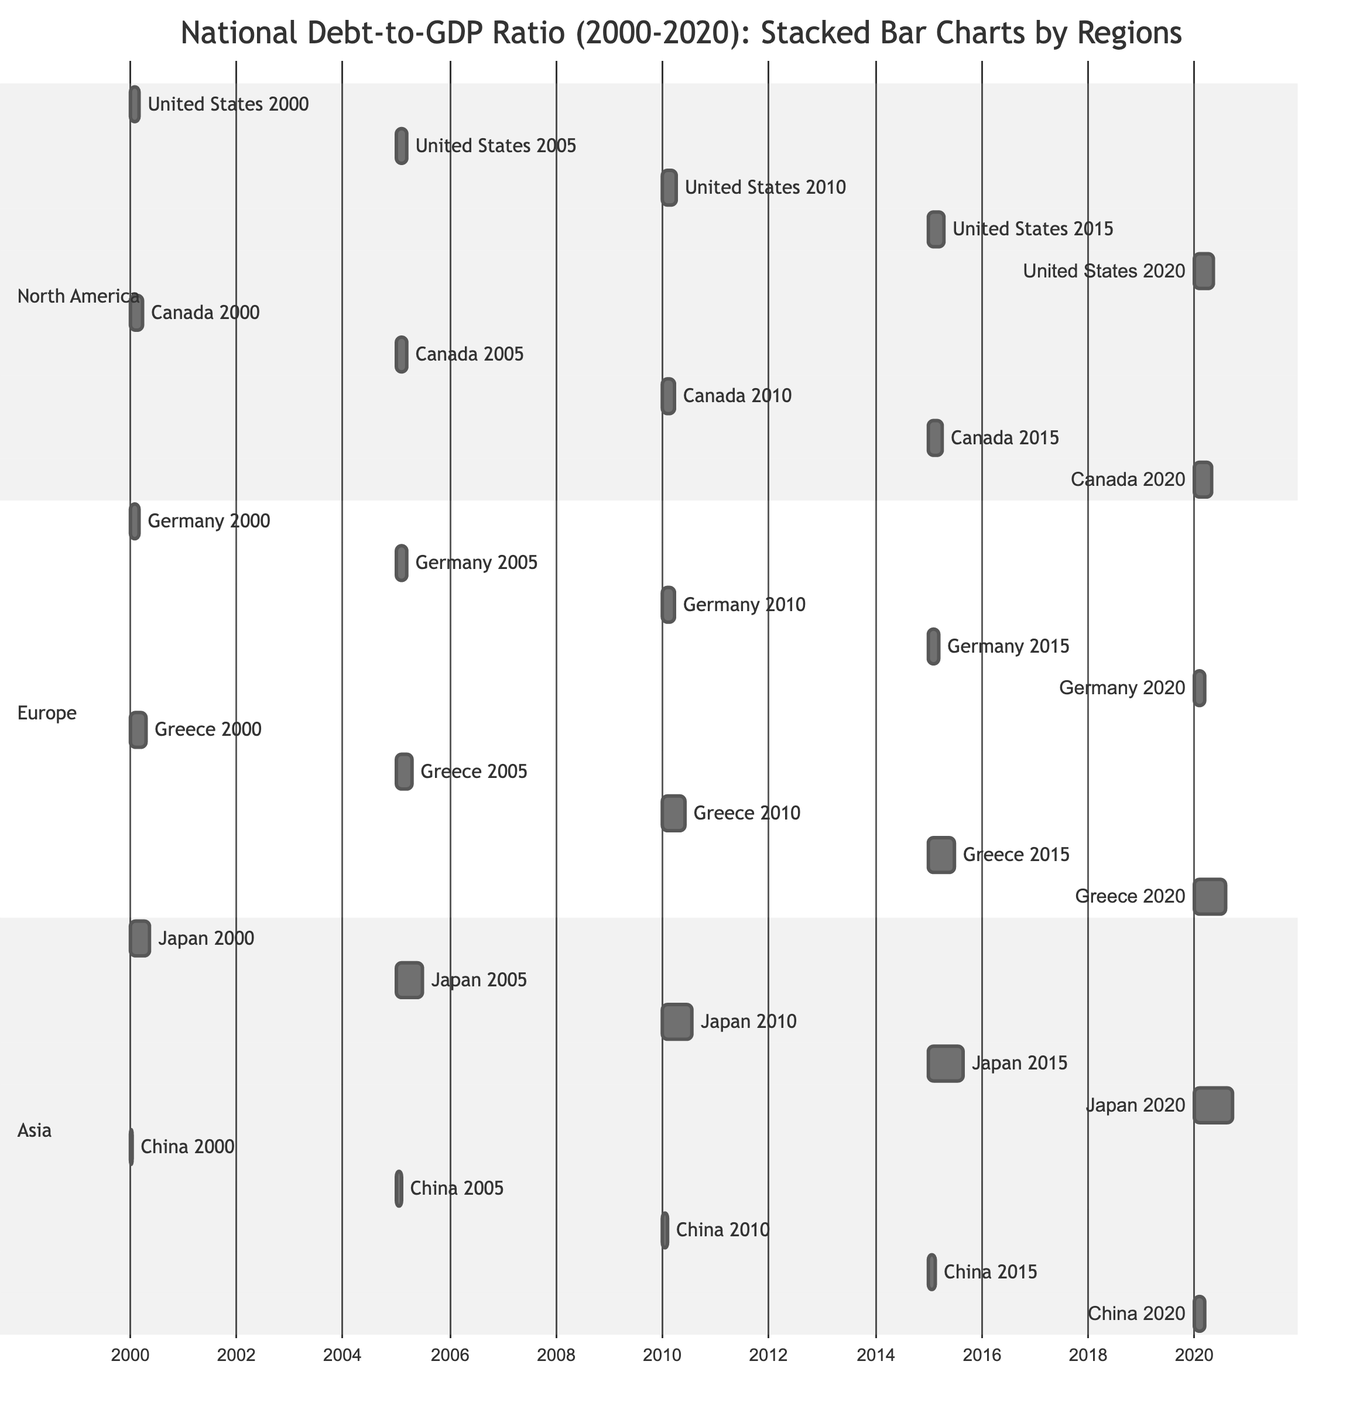What was the debt-to-GDP ratio of the United States in 2010? The diagram indicates that the debt-to-GDP ratio for the United States in 2010 is represented by the value 91.
Answer: 91 What was the highest debt-to-GDP ratio recorded by Greece in the given period? The diagram shows that Greece's highest debt-to-GDP ratio occurred in 2020, with a value of 206.
Answer: 206 Which country had the lowest debt-to-GDP ratio in 2000? By examining the diagram, the ratio for China in 2000 is the lowest at 17 compared to other countries in that year.
Answer: 17 In what year did Japan's debt-to-GDP ratio exceed 200? Assessing the values in the diagram, Japan's debt-to-GDP ratio exceeded 200 for the first time in 2015 when it reached 234.
Answer: 2015 Which region experienced the highest increase in debt-to-GDP ratio from 2000 to 2020? By comparing the values for each region, Japan in Asia shows a significant increase from 137 in 2000 to 257 in 2020, leading to the highest increase of 120.
Answer: Asia How many countries in Europe had a debt-to-GDP ratio above 100 in 2015? Analyzing the data in the diagram, Germany had 71, while Greece had 177, indicating only Greece was above 100. Thus, there was one country above 100.
Answer: 1 What was the total debt-to-GDP ratio for North America in 2020? To find the total, the ratios for both the United States and Canada in 2020 are added together: 129 + 118. This total is 247.
Answer: 247 In which year did Canada have a higher debt-to-GDP ratio than Germany? The values show that from 2000 to 2020, Canada's ratio was higher than Germany's in the years 2010 (Canada 83, Germany 82) and 2015 (Canada 91, Germany 71). The first such instance was in 2010.
Answer: 2010 What is the debt-to-GDP ratio trend for China from 2000 to 2020? Analyzing the data, China's ratios began at 17 in 2000 and increased each year through 2020, reaching a final value of 67, indicating a consistent upward trend.
Answer: Upward trend 